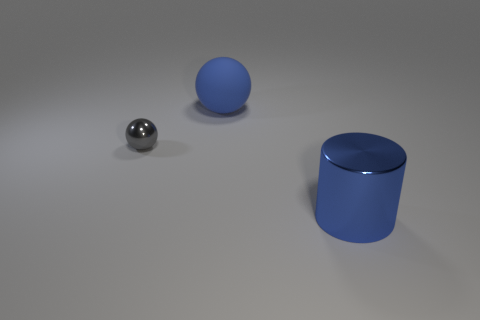What number of other large matte spheres are the same color as the large matte sphere?
Your answer should be very brief. 0. Are there any large cylinders in front of the small gray thing?
Provide a short and direct response. Yes. Is the number of blue objects left of the small metal object the same as the number of blue cylinders that are behind the cylinder?
Offer a terse response. Yes. There is a metal thing that is behind the large metal cylinder; is its size the same as the metal object to the right of the gray ball?
Offer a terse response. No. What is the shape of the thing that is behind the sphere in front of the big blue object that is behind the tiny gray sphere?
Give a very brief answer. Sphere. Is there anything else that has the same material as the large blue cylinder?
Ensure brevity in your answer.  Yes. There is a matte thing that is the same shape as the gray metal object; what is its size?
Ensure brevity in your answer.  Large. There is a object that is left of the large blue metallic object and in front of the large blue rubber sphere; what is its color?
Offer a very short reply. Gray. Are the blue cylinder and the object that is left of the blue rubber object made of the same material?
Give a very brief answer. Yes. Is the number of things on the right side of the blue cylinder less than the number of rubber things?
Make the answer very short. Yes. 